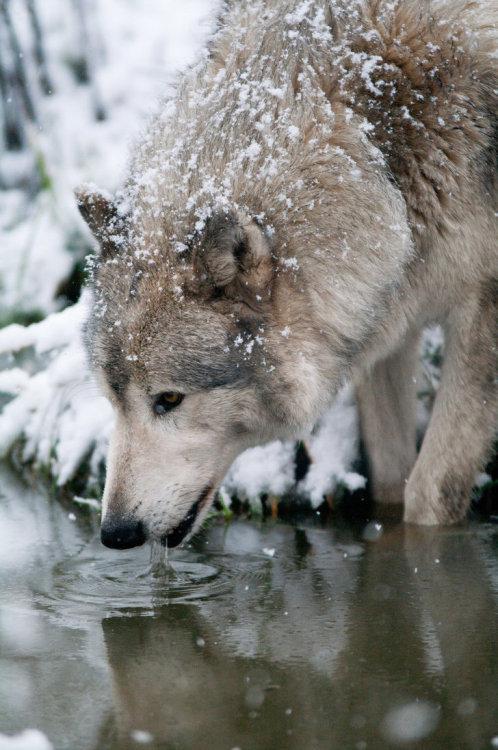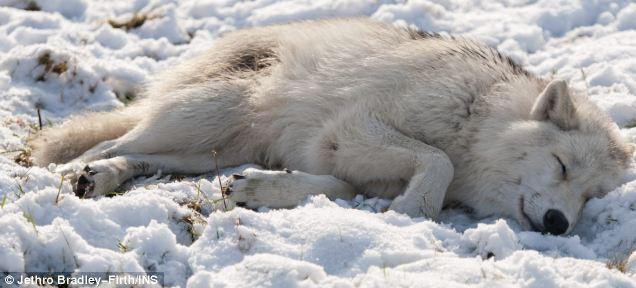The first image is the image on the left, the second image is the image on the right. Analyze the images presented: Is the assertion "A canine can be seen laying on the ground." valid? Answer yes or no. Yes. The first image is the image on the left, the second image is the image on the right. For the images displayed, is the sentence "An animal is laying down." factually correct? Answer yes or no. Yes. 